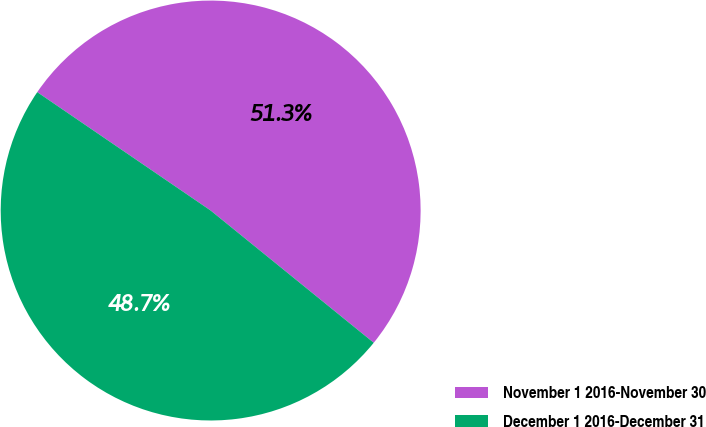Convert chart to OTSL. <chart><loc_0><loc_0><loc_500><loc_500><pie_chart><fcel>November 1 2016-November 30<fcel>December 1 2016-December 31<nl><fcel>51.31%<fcel>48.69%<nl></chart> 